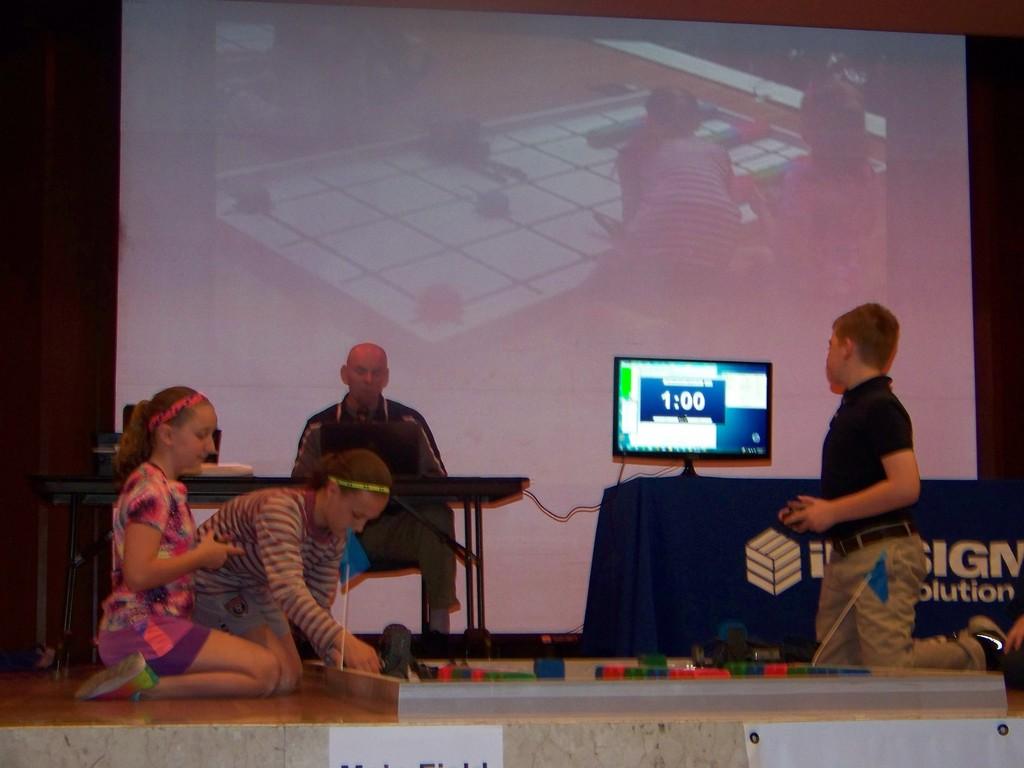How much time is left on the clock on the monitor?
Provide a succinct answer. 1:00. 